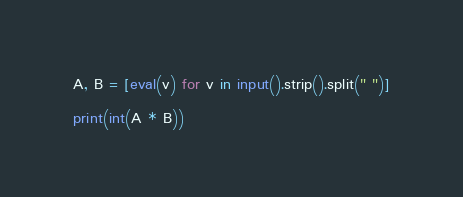Convert code to text. <code><loc_0><loc_0><loc_500><loc_500><_Python_>A, B = [eval(v) for v in input().strip().split(" ")]

print(int(A * B))</code> 